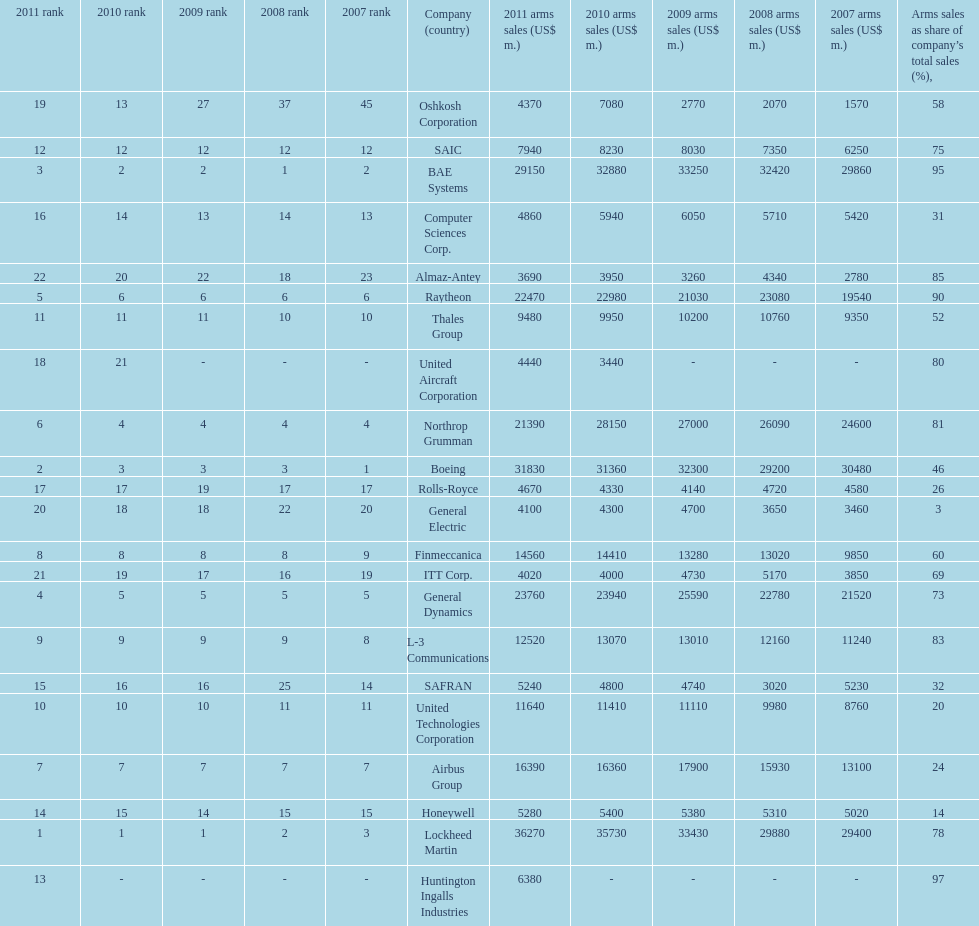Calculate the difference between boeing's 2010 arms sales and raytheon's 2010 arms sales. 8380. Would you mind parsing the complete table? {'header': ['2011 rank', '2010 rank', '2009 rank', '2008 rank', '2007 rank', 'Company (country)', '2011 arms sales (US$ m.)', '2010 arms sales (US$ m.)', '2009 arms sales (US$ m.)', '2008 arms sales (US$ m.)', '2007 arms sales (US$ m.)', 'Arms sales as share of company’s total sales (%),'], 'rows': [['19', '13', '27', '37', '45', 'Oshkosh Corporation', '4370', '7080', '2770', '2070', '1570', '58'], ['12', '12', '12', '12', '12', 'SAIC', '7940', '8230', '8030', '7350', '6250', '75'], ['3', '2', '2', '1', '2', 'BAE Systems', '29150', '32880', '33250', '32420', '29860', '95'], ['16', '14', '13', '14', '13', 'Computer Sciences Corp.', '4860', '5940', '6050', '5710', '5420', '31'], ['22', '20', '22', '18', '23', 'Almaz-Antey', '3690', '3950', '3260', '4340', '2780', '85'], ['5', '6', '6', '6', '6', 'Raytheon', '22470', '22980', '21030', '23080', '19540', '90'], ['11', '11', '11', '10', '10', 'Thales Group', '9480', '9950', '10200', '10760', '9350', '52'], ['18', '21', '-', '-', '-', 'United Aircraft Corporation', '4440', '3440', '-', '-', '-', '80'], ['6', '4', '4', '4', '4', 'Northrop Grumman', '21390', '28150', '27000', '26090', '24600', '81'], ['2', '3', '3', '3', '1', 'Boeing', '31830', '31360', '32300', '29200', '30480', '46'], ['17', '17', '19', '17', '17', 'Rolls-Royce', '4670', '4330', '4140', '4720', '4580', '26'], ['20', '18', '18', '22', '20', 'General Electric', '4100', '4300', '4700', '3650', '3460', '3'], ['8', '8', '8', '8', '9', 'Finmeccanica', '14560', '14410', '13280', '13020', '9850', '60'], ['21', '19', '17', '16', '19', 'ITT Corp.', '4020', '4000', '4730', '5170', '3850', '69'], ['4', '5', '5', '5', '5', 'General Dynamics', '23760', '23940', '25590', '22780', '21520', '73'], ['9', '9', '9', '9', '8', 'L-3 Communications', '12520', '13070', '13010', '12160', '11240', '83'], ['15', '16', '16', '25', '14', 'SAFRAN', '5240', '4800', '4740', '3020', '5230', '32'], ['10', '10', '10', '11', '11', 'United Technologies Corporation', '11640', '11410', '11110', '9980', '8760', '20'], ['7', '7', '7', '7', '7', 'Airbus Group', '16390', '16360', '17900', '15930', '13100', '24'], ['14', '15', '14', '15', '15', 'Honeywell', '5280', '5400', '5380', '5310', '5020', '14'], ['1', '1', '1', '2', '3', 'Lockheed Martin', '36270', '35730', '33430', '29880', '29400', '78'], ['13', '-', '-', '-', '-', 'Huntington Ingalls Industries', '6380', '-', '-', '-', '-', '97']]} 